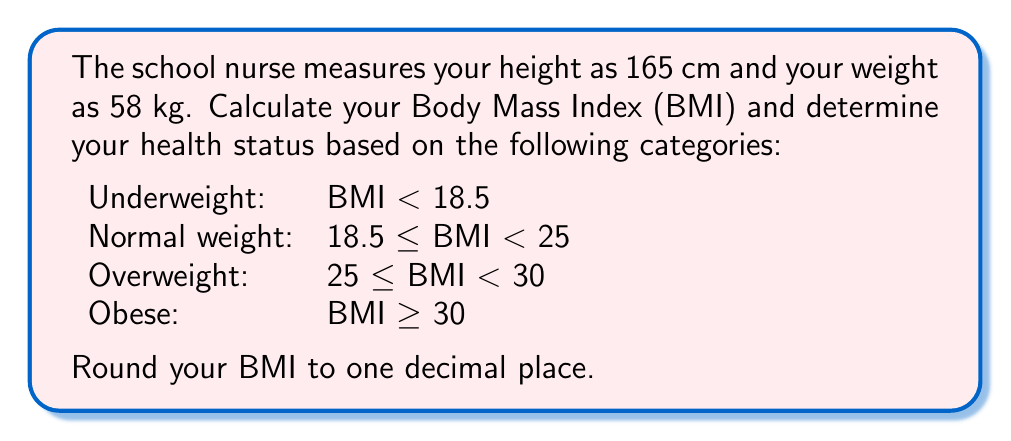What is the answer to this math problem? To calculate the Body Mass Index (BMI), we use the formula:

$$BMI = \frac{weight (kg)}{[height (m)]^2}$$

Step 1: Convert height from cm to m
$165 \text{ cm} = 1.65 \text{ m}$

Step 2: Calculate BMI
$$BMI = \frac{58}{1.65^2} = \frac{58}{2.7225} \approx 21.3030$$

Step 3: Round to one decimal place
$BMI \approx 21.3$

Step 4: Determine health status
Since $18.5 \leq 21.3 < 25$, the BMI falls within the "Normal weight" category.
Answer: BMI: 21.3, Normal weight 